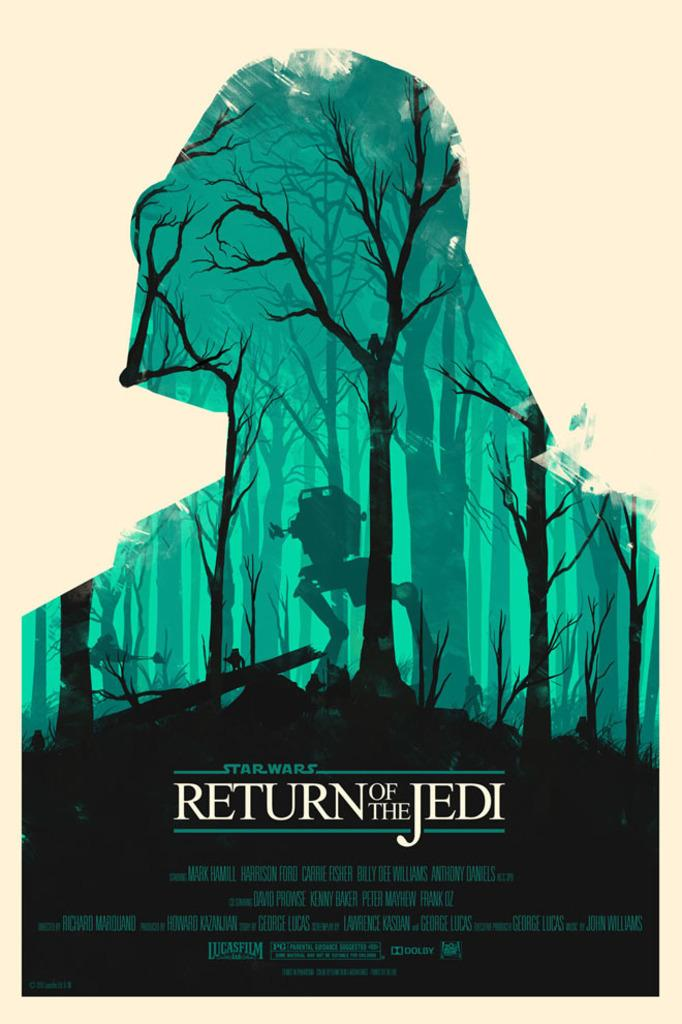What is depicted in the painting in the image? There is a painting of trees in the image. Are there any additional elements on the painting besides the trees? Yes, there is writing on the painting. How many nerves can be seen in the painting? There are no nerves depicted in the painting; it features trees and writing. What type of wing is visible on the painting? There is no wing present in the painting; it features trees and writing. 